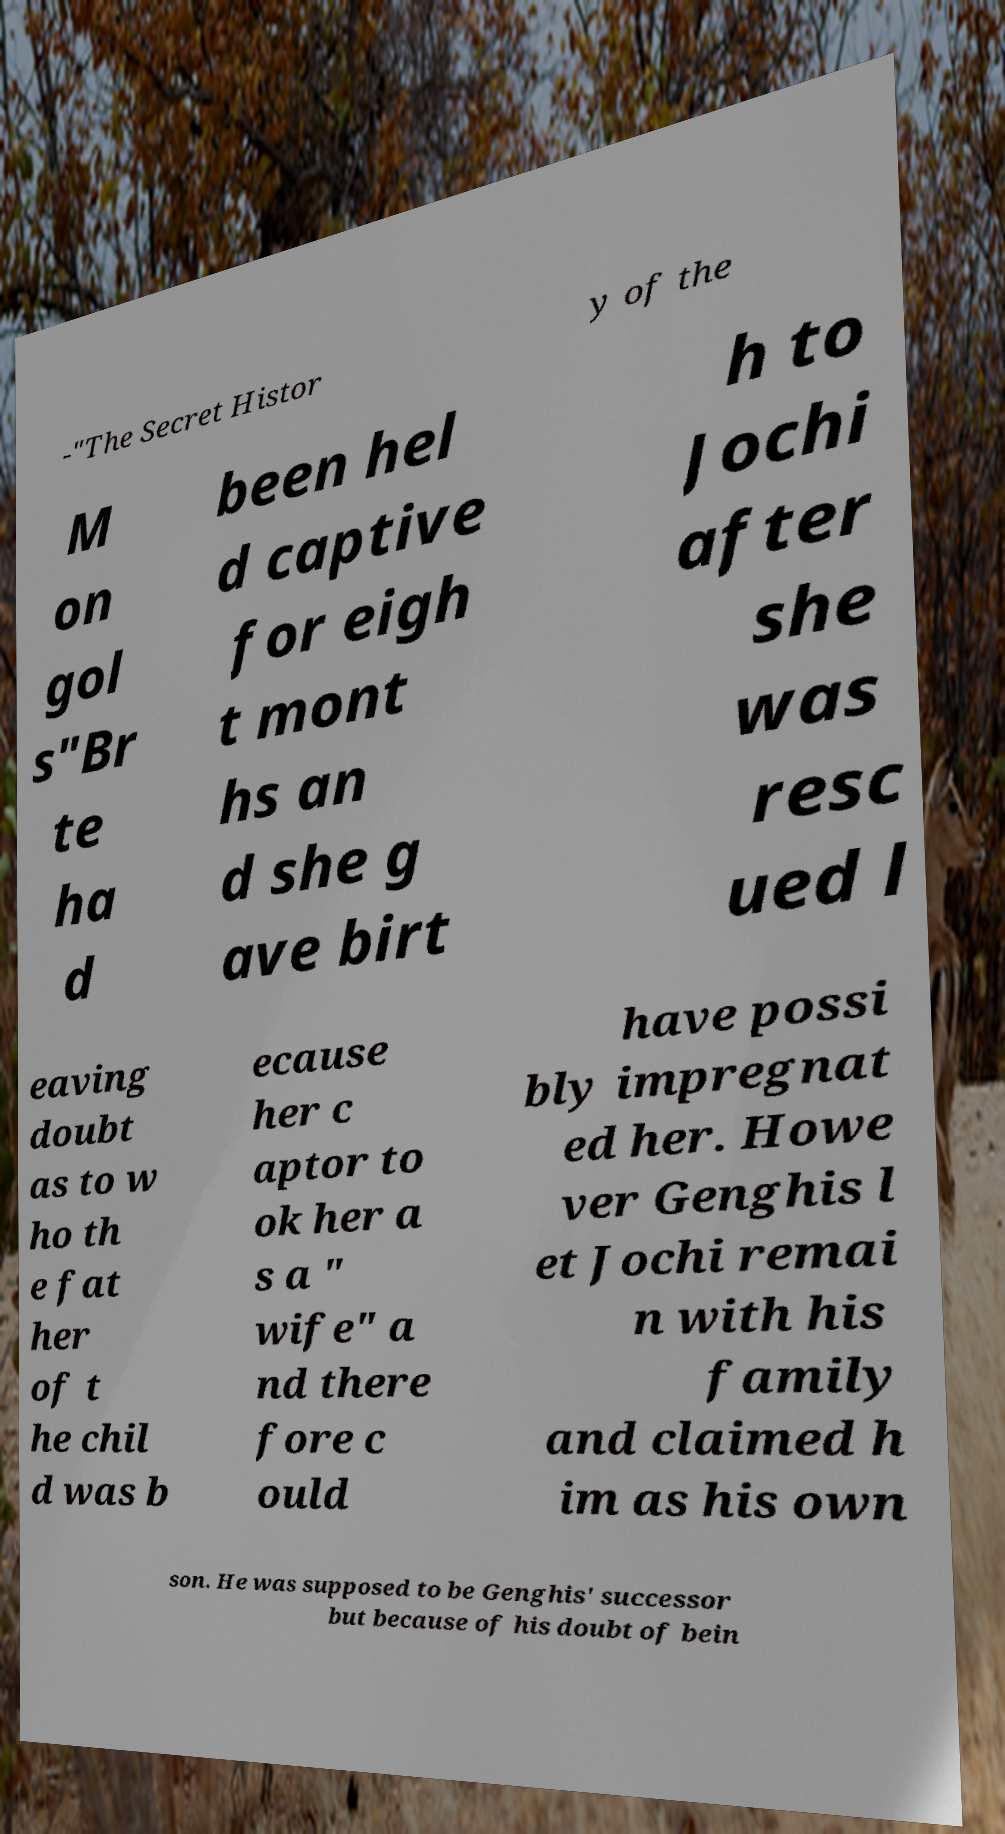Could you assist in decoding the text presented in this image and type it out clearly? -"The Secret Histor y of the M on gol s"Br te ha d been hel d captive for eigh t mont hs an d she g ave birt h to Jochi after she was resc ued l eaving doubt as to w ho th e fat her of t he chil d was b ecause her c aptor to ok her a s a " wife" a nd there fore c ould have possi bly impregnat ed her. Howe ver Genghis l et Jochi remai n with his family and claimed h im as his own son. He was supposed to be Genghis' successor but because of his doubt of bein 